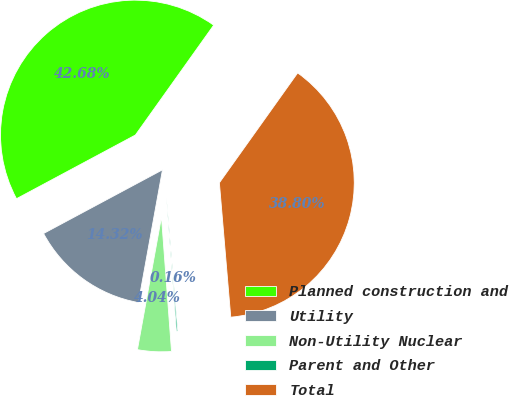<chart> <loc_0><loc_0><loc_500><loc_500><pie_chart><fcel>Planned construction and<fcel>Utility<fcel>Non-Utility Nuclear<fcel>Parent and Other<fcel>Total<nl><fcel>42.68%<fcel>14.32%<fcel>4.04%<fcel>0.16%<fcel>38.8%<nl></chart> 